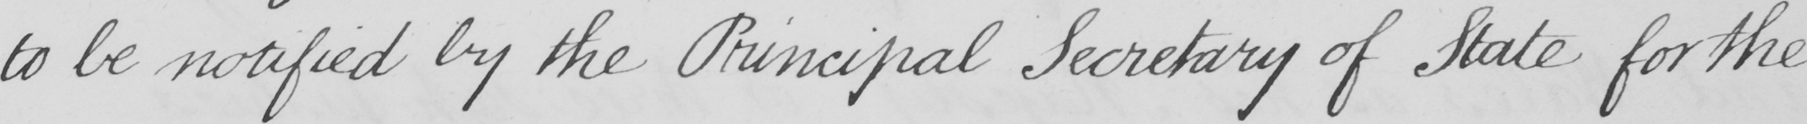Can you read and transcribe this handwriting? to be notified by the Principal Secretary of State for the 